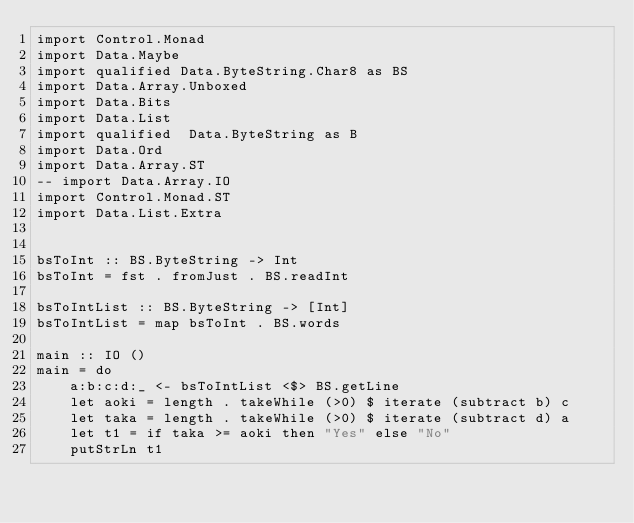<code> <loc_0><loc_0><loc_500><loc_500><_Haskell_>import Control.Monad
import Data.Maybe
import qualified Data.ByteString.Char8 as BS
import Data.Array.Unboxed
import Data.Bits
import Data.List
import qualified  Data.ByteString as B
import Data.Ord
import Data.Array.ST
-- import Data.Array.IO 
import Control.Monad.ST
import Data.List.Extra


bsToInt :: BS.ByteString -> Int
bsToInt = fst . fromJust . BS.readInt

bsToIntList :: BS.ByteString -> [Int]
bsToIntList = map bsToInt . BS.words

main :: IO ()
main = do
    a:b:c:d:_ <- bsToIntList <$> BS.getLine
    let aoki = length . takeWhile (>0) $ iterate (subtract b) c
    let taka = length . takeWhile (>0) $ iterate (subtract d) a
    let t1 = if taka >= aoki then "Yes" else "No"
    putStrLn t1</code> 